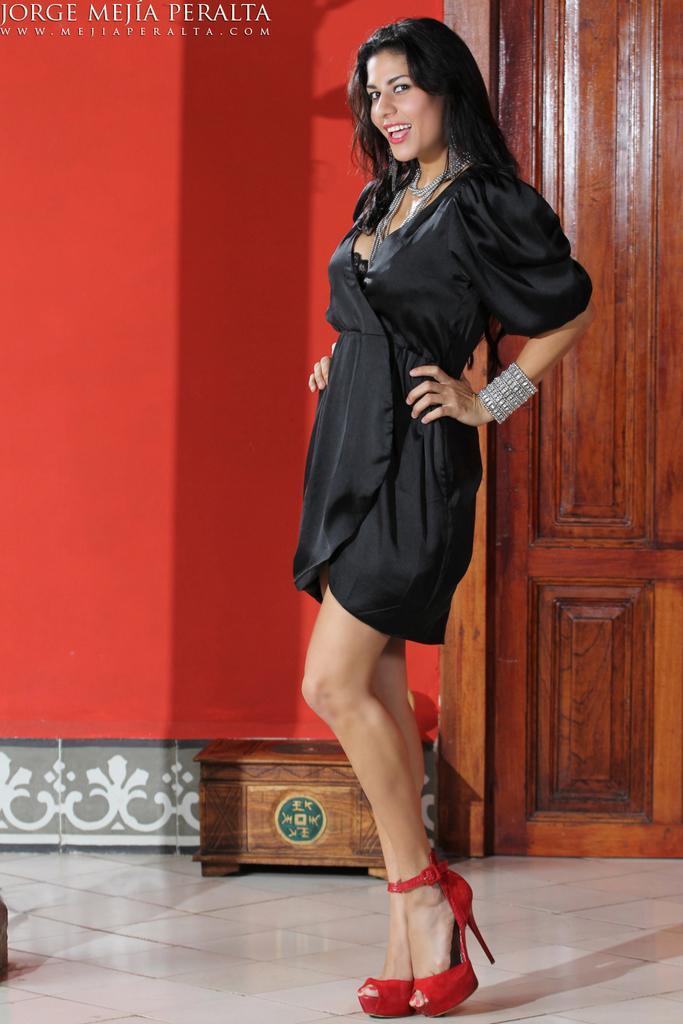Can you describe this image briefly? In this picture I can see a woman standing and smiling, there is an wooden object, there is a door, and in the background there is a wall and there is a watermark on the image. 